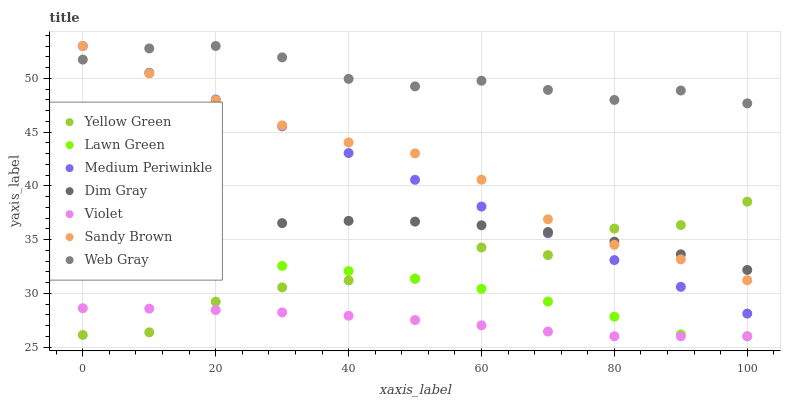Does Violet have the minimum area under the curve?
Answer yes or no. Yes. Does Web Gray have the maximum area under the curve?
Answer yes or no. Yes. Does Dim Gray have the minimum area under the curve?
Answer yes or no. No. Does Dim Gray have the maximum area under the curve?
Answer yes or no. No. Is Medium Periwinkle the smoothest?
Answer yes or no. Yes. Is Yellow Green the roughest?
Answer yes or no. Yes. Is Dim Gray the smoothest?
Answer yes or no. No. Is Dim Gray the roughest?
Answer yes or no. No. Does Lawn Green have the lowest value?
Answer yes or no. Yes. Does Dim Gray have the lowest value?
Answer yes or no. No. Does Sandy Brown have the highest value?
Answer yes or no. Yes. Does Dim Gray have the highest value?
Answer yes or no. No. Is Violet less than Medium Periwinkle?
Answer yes or no. Yes. Is Dim Gray greater than Lawn Green?
Answer yes or no. Yes. Does Medium Periwinkle intersect Sandy Brown?
Answer yes or no. Yes. Is Medium Periwinkle less than Sandy Brown?
Answer yes or no. No. Is Medium Periwinkle greater than Sandy Brown?
Answer yes or no. No. Does Violet intersect Medium Periwinkle?
Answer yes or no. No. 